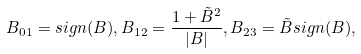<formula> <loc_0><loc_0><loc_500><loc_500>B _ { 0 1 } = s i g n ( B ) , B _ { 1 2 } = \frac { 1 + \tilde { B } ^ { 2 } } { | B | } , B _ { 2 3 } = \tilde { B } s i g n ( B ) ,</formula> 